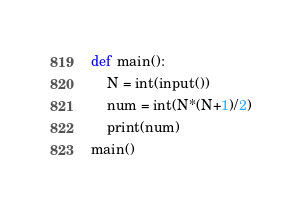Convert code to text. <code><loc_0><loc_0><loc_500><loc_500><_Python_>def main():
    N = int(input())
    num = int(N*(N+1)/2)
    print(num)
main()</code> 